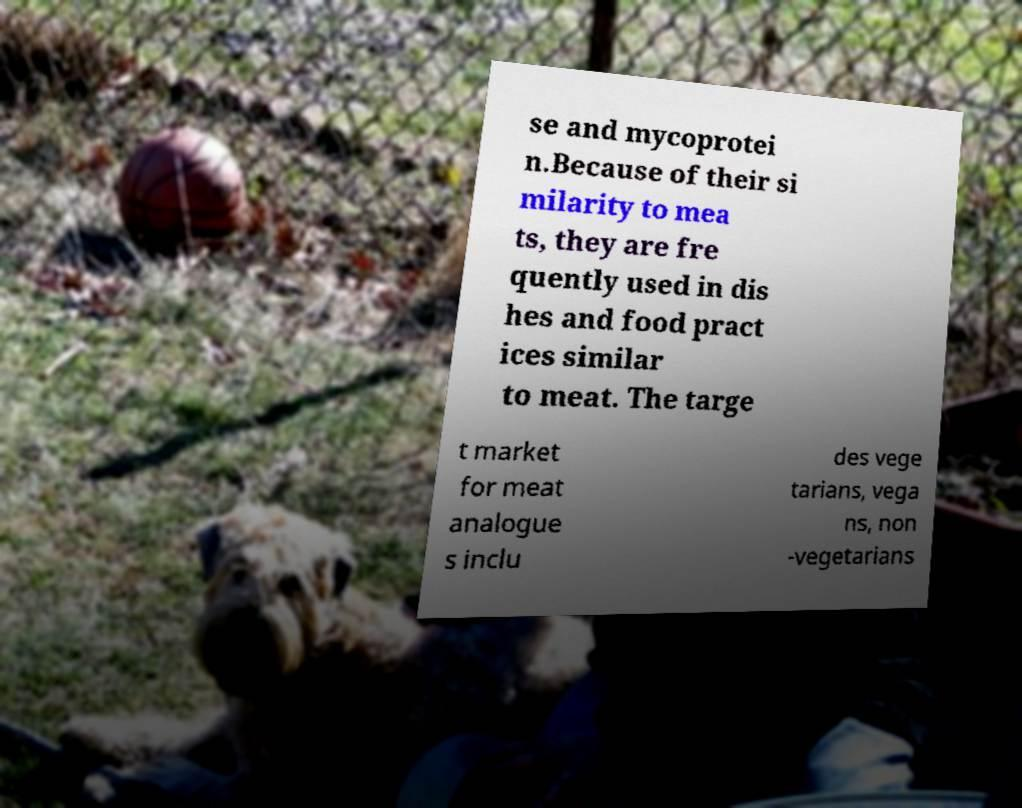Can you accurately transcribe the text from the provided image for me? se and mycoprotei n.Because of their si milarity to mea ts, they are fre quently used in dis hes and food pract ices similar to meat. The targe t market for meat analogue s inclu des vege tarians, vega ns, non -vegetarians 